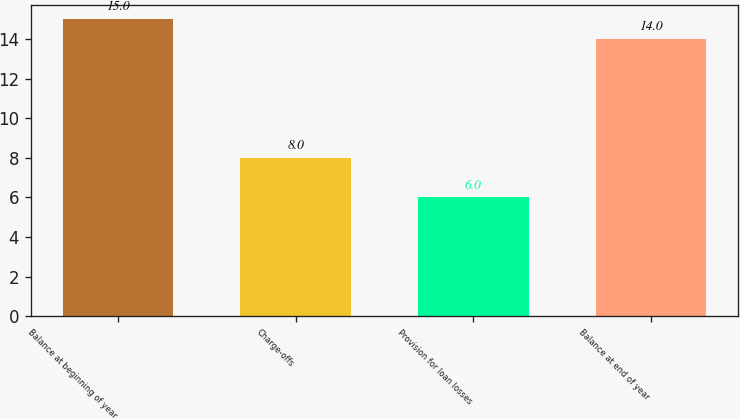Convert chart to OTSL. <chart><loc_0><loc_0><loc_500><loc_500><bar_chart><fcel>Balance at beginning of year<fcel>Charge-offs<fcel>Provision for loan losses<fcel>Balance at end of year<nl><fcel>15<fcel>8<fcel>6<fcel>14<nl></chart> 